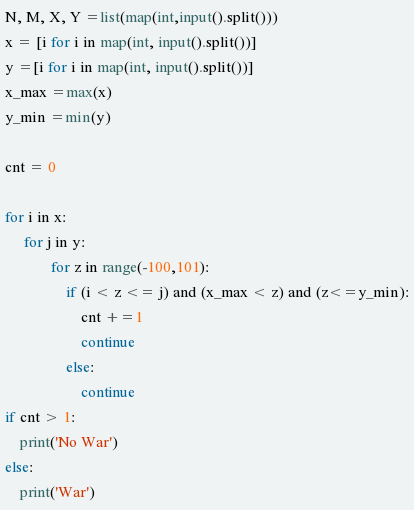Convert code to text. <code><loc_0><loc_0><loc_500><loc_500><_Python_>N, M, X, Y =list(map(int,input().split()))
x = [i for i in map(int, input().split())]        
y =[i for i in map(int, input().split())]
x_max =max(x)
y_min =min(y)

cnt = 0

for i in x:
     for j in y:
            for z in range(-100,101):
                if (i < z <= j) and (x_max < z) and (z<=y_min):
                    cnt +=1
                    continue
                else:
                    continue
if cnt > 1:
    print('No War')
else:
    print('War')</code> 